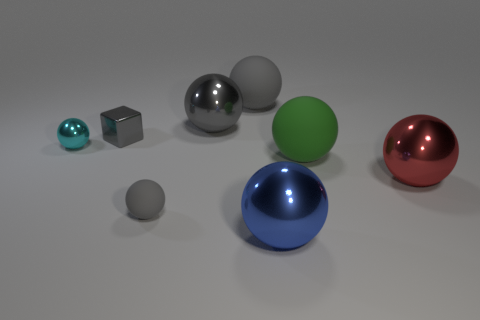How many gray spheres must be subtracted to get 1 gray spheres? 2 Subtract all cyan blocks. How many gray balls are left? 3 Subtract all red spheres. How many spheres are left? 6 Subtract all small rubber balls. How many balls are left? 6 Subtract all blue spheres. Subtract all yellow blocks. How many spheres are left? 6 Add 1 red shiny balls. How many objects exist? 9 Subtract all cubes. How many objects are left? 7 Subtract 1 gray blocks. How many objects are left? 7 Subtract all small matte cylinders. Subtract all small metallic things. How many objects are left? 6 Add 1 balls. How many balls are left? 8 